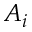Convert formula to latex. <formula><loc_0><loc_0><loc_500><loc_500>A _ { i }</formula> 